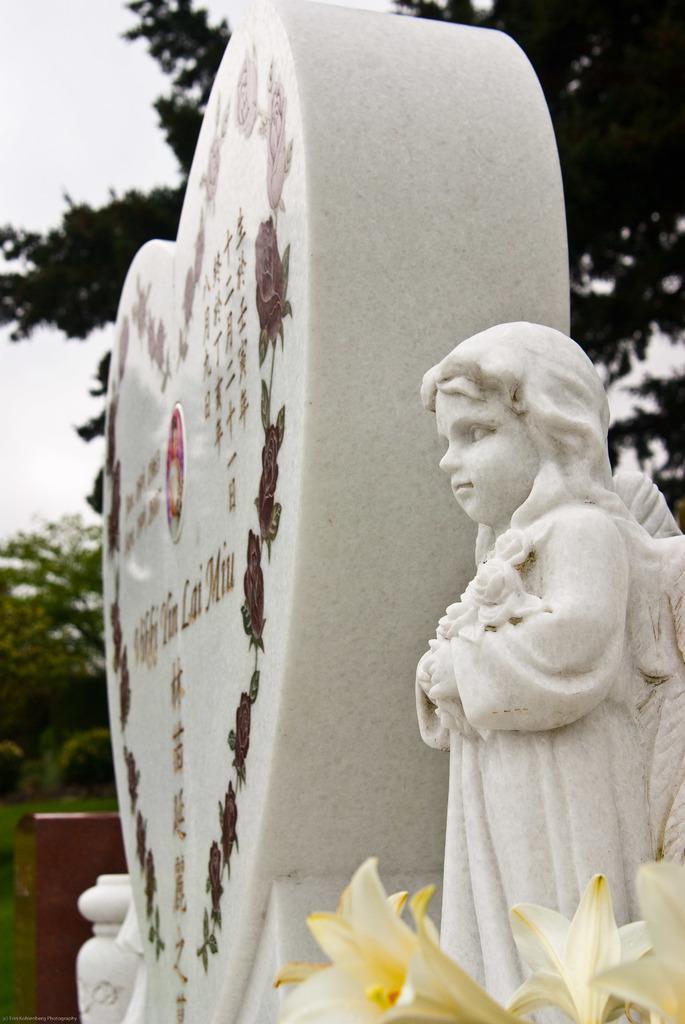Can you describe this image briefly? In this image there are flowers, sculptures, and in the background there are trees,sky. 